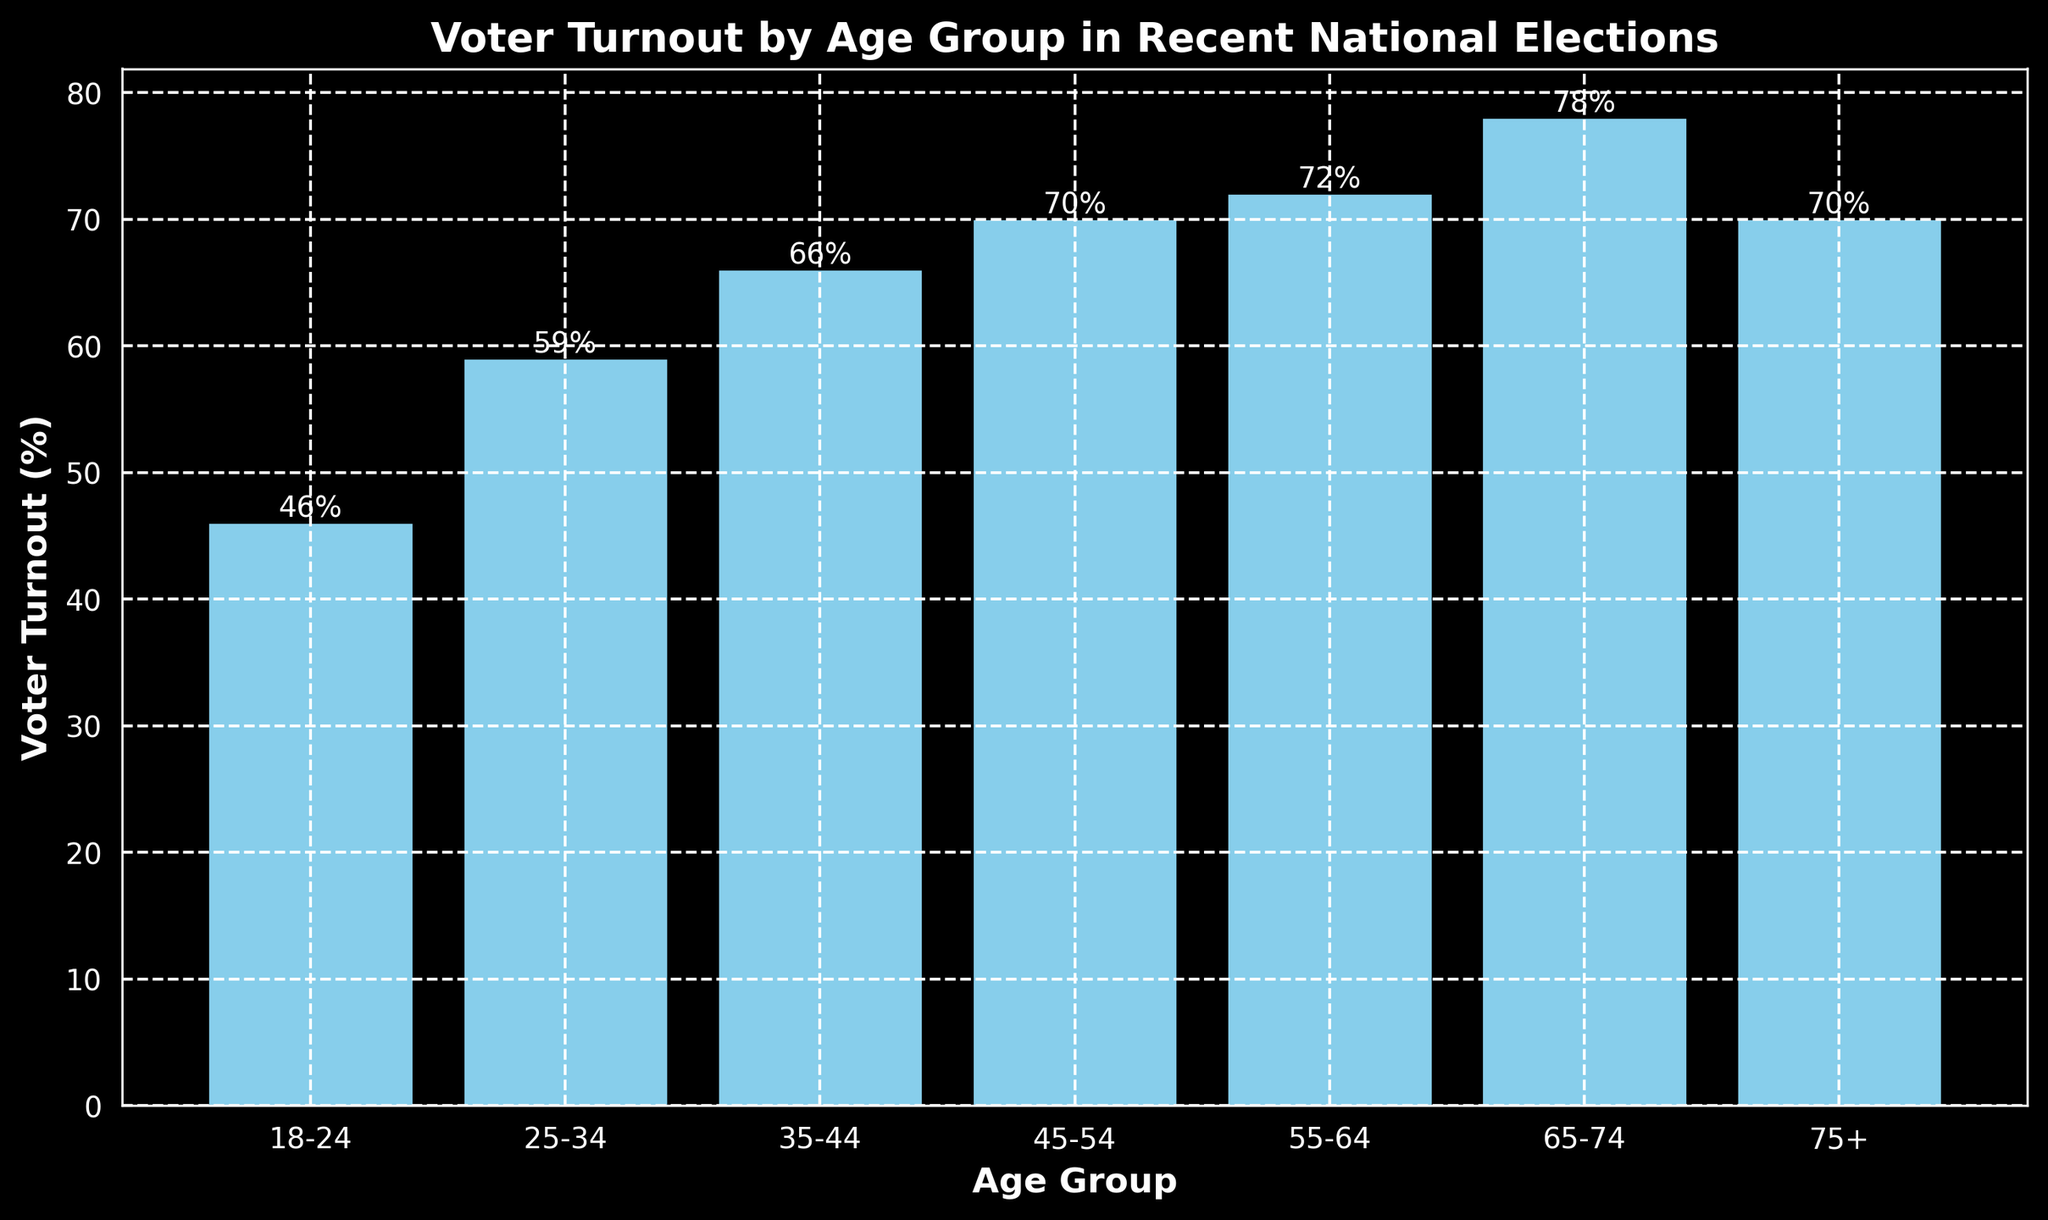What age group has the highest voter turnout percentage? The bar representing the age group 65-74 is the tallest, indicating the highest voter turnout percentage among all age groups.
Answer: 65-74 Which age group has a lower voter turnout percentage, 18-24 or 25-34? The bar for the age group 18-24 is shorter than the bar for the age group 25-34, indicating a lower voter turnout percentage.
Answer: 18-24 How much greater is the voter turnout percentage for the 55-64 age group compared to the 35-44 age group? The voter turnout for 55-64 is 72%, and for 35-44 it is 66%. The difference is calculated as 72% - 66% = 6%.
Answer: 6% Which age groups have a voter turnout percentage greater than 70%? The bars for the age groups 55-64, 65-74, and 75+ exceed the 70% marker on the y-axis.
Answer: 55-64, 65-74, 75+ What is the average voter turnout percentage for the age groups 18-24, 25-34, and 35-44? Sum the percentages of the three groups (46% + 59% + 66% = 171%), then divide by the number of groups (171% / 3).
Answer: 57% Do more age groups have a voter turnout percentage below 70% or above 70%? Age groups below 70%: 18-24, 25-34, 35-44. Age groups above 70%: 55-64, 65-74, 75+. Each has three groups.
Answer: Equal number What is the combined voter turnout percentage of the oldest two age groups? Add the percentages for the 65-74 group (78%) and the 75+ group (70%). The combined turnout is 78% + 70% = 148%.
Answer: 148% Which age group experienced a 6% increase in voter turnout compared to the previous younger age group? Comparing the differences: 
18-24 to 25-34 is 59% - 46% = 13%
25-34 to 35-44 is 66% - 59% = 7%
35-44 to 45-54 is 70% - 66% = 4%
45-54 to 55-64 is 72% - 70% = 2%
55-64 to 65-74 is 78% - 72% = 6%
The age group 65-74 experienced a 6% increase compared to 55-64.
Answer: 65-74 What is the range of voter turnout percentages across all age groups? The range is found by subtracting the smallest percentage (46% for 18-24) from the largest percentage (78% for 65-74), resulting in: 78% - 46% = 32%.
Answer: 32% Which age group has a turnout percentage equal to 70%? The bars for the age groups 45-54 and 75+ both reach the 70% mark on the y-axis.
Answer: 45-54, 75+ 